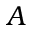<formula> <loc_0><loc_0><loc_500><loc_500>A</formula> 